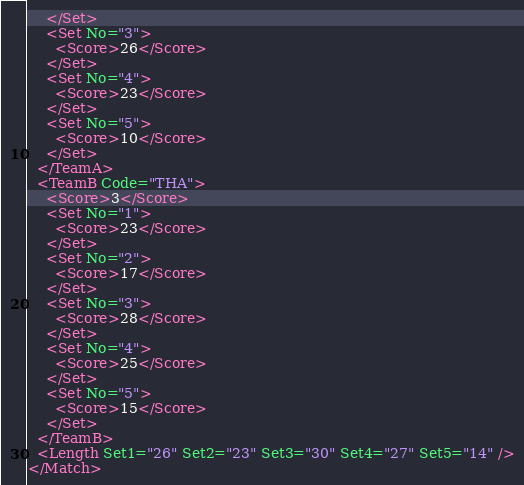<code> <loc_0><loc_0><loc_500><loc_500><_XML_>    </Set>
    <Set No="3">
      <Score>26</Score>
    </Set>
    <Set No="4">
      <Score>23</Score>
    </Set>
    <Set No="5">
      <Score>10</Score>
    </Set>
  </TeamA>
  <TeamB Code="THA">
    <Score>3</Score>
    <Set No="1">
      <Score>23</Score>
    </Set>
    <Set No="2">
      <Score>17</Score>
    </Set>
    <Set No="3">
      <Score>28</Score>
    </Set>
    <Set No="4">
      <Score>25</Score>
    </Set>
    <Set No="5">
      <Score>15</Score>
    </Set>
  </TeamB>
  <Length Set1="26" Set2="23" Set3="30" Set4="27" Set5="14" />
</Match></code> 